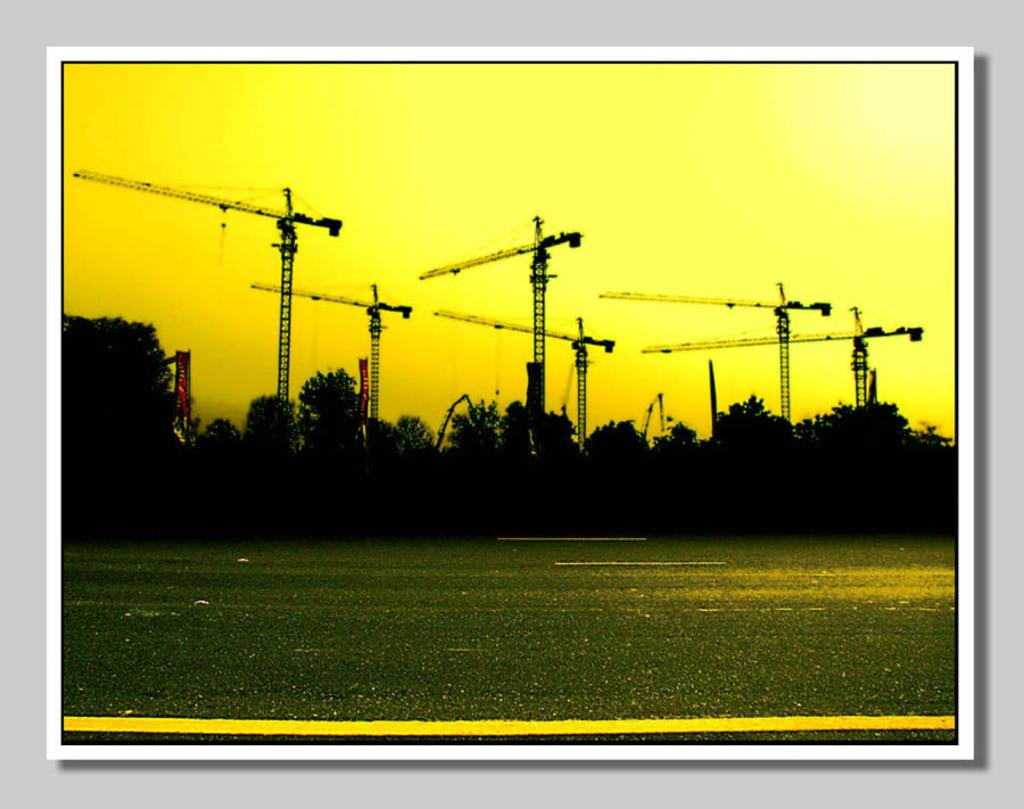What is the main feature of the image? There is a road in the image. What can be seen beside the road? There are trees beside the road. What is visible in the background of the image? There are cranes in the background of the image. How far is the distance between the trees and the cranes in the image? The provided facts do not give information about the distance between the trees and the cranes, so it cannot be determined from the image. 